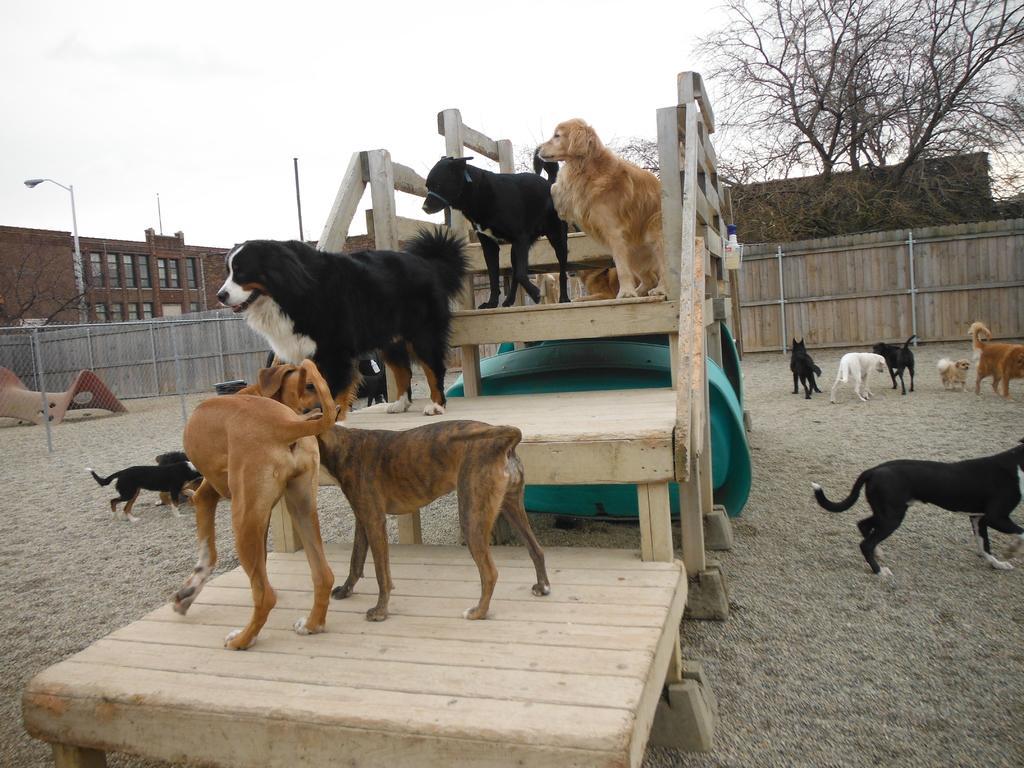Can you describe this image briefly? In this image we can see dogs on the ground and on the stairs. In the background we can see buildings, trees, mesh, street lights, street poles and sky. 